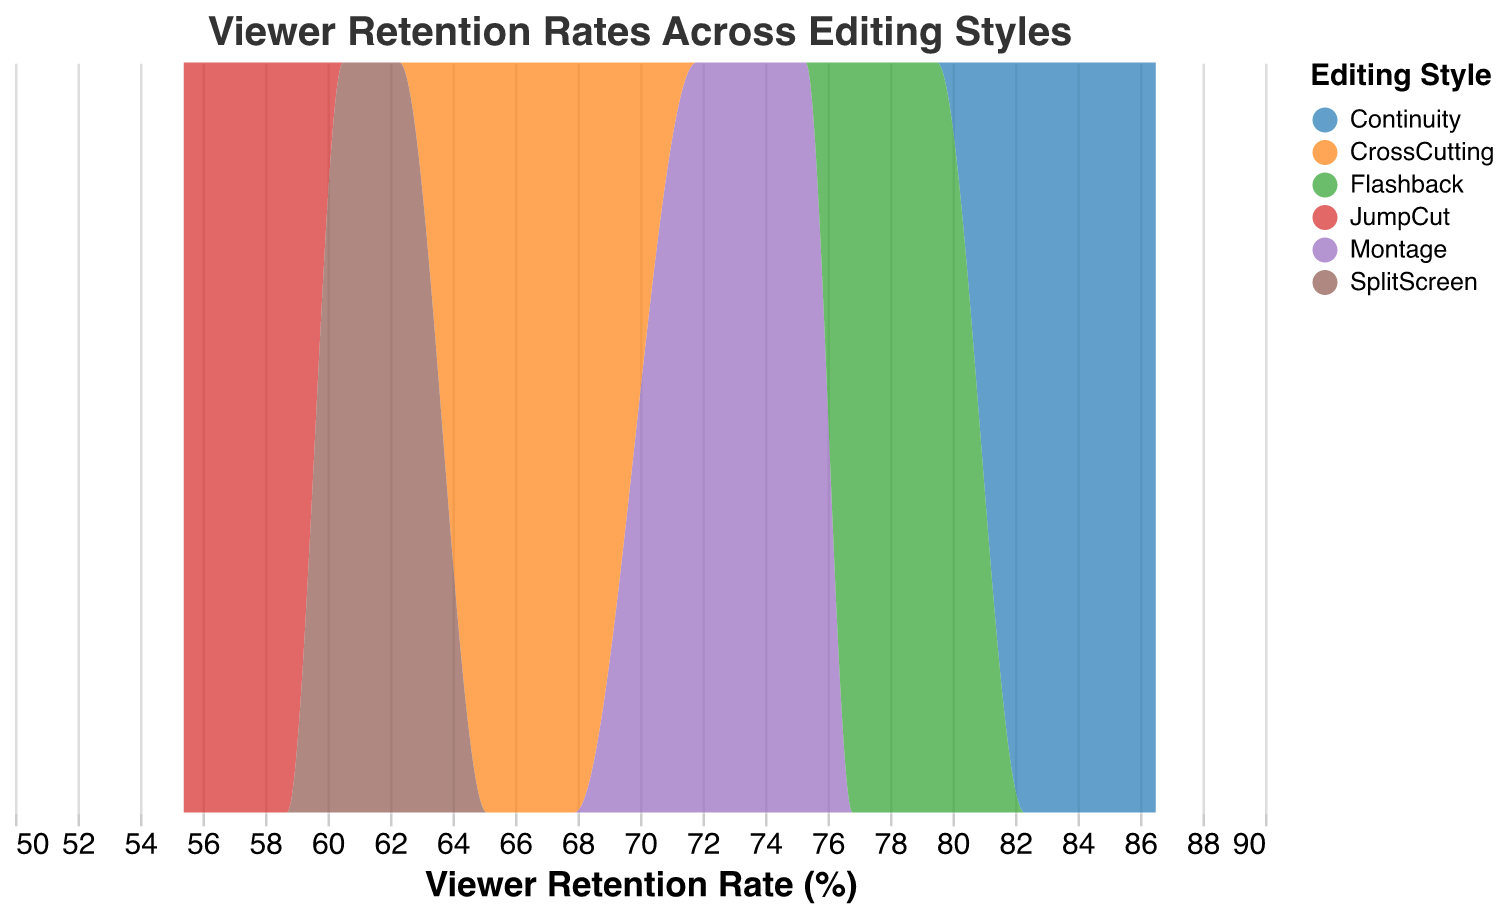What is the title of the density plot? The title is located at the top of the plot and usually indicates the main topic or variable being analyzed. Here, the title "Viewer Retention Rates Across Editing Styles" provides a summary of the analysis.
Answer: Viewer Retention Rates Across Editing Styles How many editing styles are compared in the plot? By looking at the different colors in the legend, we can see the number of distinct editing styles displayed. There are six distinct colors representing six editing styles.
Answer: Six Which editing style has the highest peak in viewer retention rates? To determine this, we look at the density distributions and identify the peak value for each editing style. "Continuity" shows the highest peak in the density plot.
Answer: Continuity Are "Montage" and "JumpCut" viewer retention rates overlapping in any region? By comparing the density curves, we can see the areas of overlap. Montage and JumpCut densities are separate and do not overlap in the viewer retention rate region.
Answer: No Which editing style shows the lowest range of viewer retention rates? The editing style's range can be observed by the start and end of its density curve. "JumpCut" shows the lowest range with rates around 55.4 to 58.7.
Answer: JumpCut What is the approximate median value of viewer retention rates for "Flashback"? The median will correspond to the central value of the displayed retention rates. Observing the density curve, the median will be around the middle of the peak values, which is approximately 78.2 to 79.5.
Answer: Around 78.2 - 78.5 How does the viewer retention rate of "SplitScreen" compare to "CrossCutting"? By comparing the peaks and ranges of the two density curves, "SplitScreen" has slightly lower viewer retention rates compared to "CrossCutting".
Answer: SplitScreen is lower than CrossCutting Which editing style shows a wide spread of viewer retention rates suggesting variability? We need to observe the width of the density curves. "Montage" has a relatively wider spread indicating more variability in viewer retention rates.
Answer: Montage What is the most common viewer retention rate value for "Continuity"? To find this, we identify the peak of the density curve for "Continuity", which corresponds to approximately 85.0 in viewer retention rate value.
Answer: 85.0 Between "Montage" and "Flashback", which has higher consistency in viewer retention rates? Consistency can be determined by the narrowness of the density curve. "Flashback" is more consistent with a narrower range compared to "Montage".
Answer: Flashback 